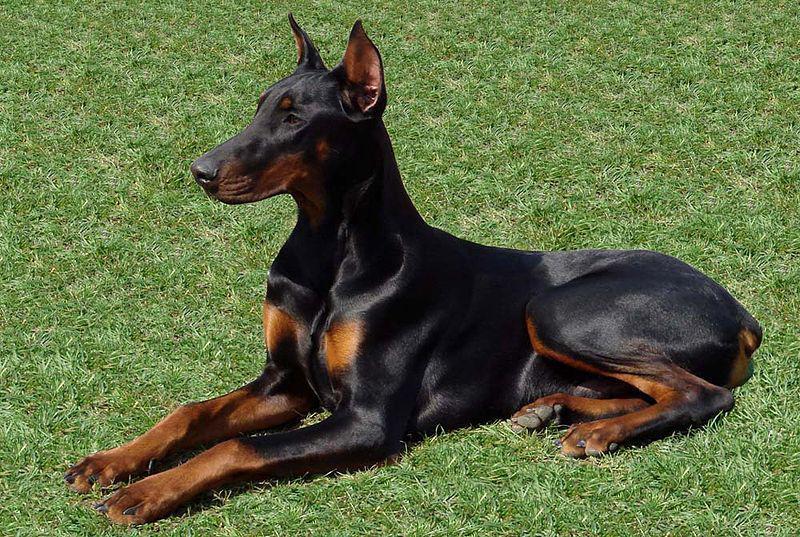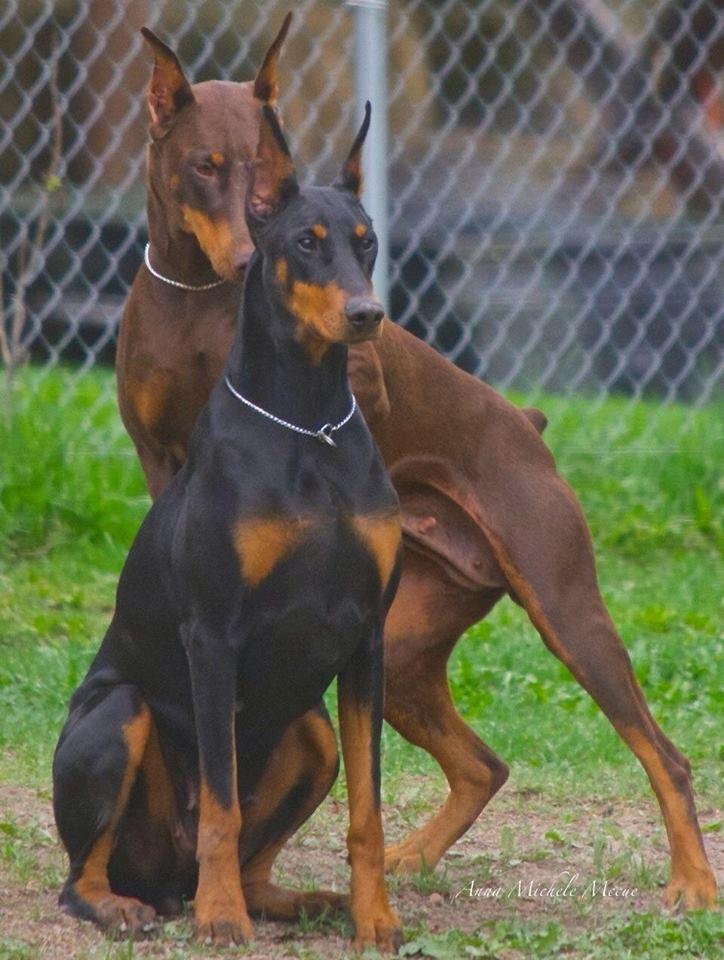The first image is the image on the left, the second image is the image on the right. For the images shown, is this caption "At least one doberman has its tongue out." true? Answer yes or no. No. The first image is the image on the left, the second image is the image on the right. Evaluate the accuracy of this statement regarding the images: "In one image, there are two dogs facing each other.". Is it true? Answer yes or no. No. 